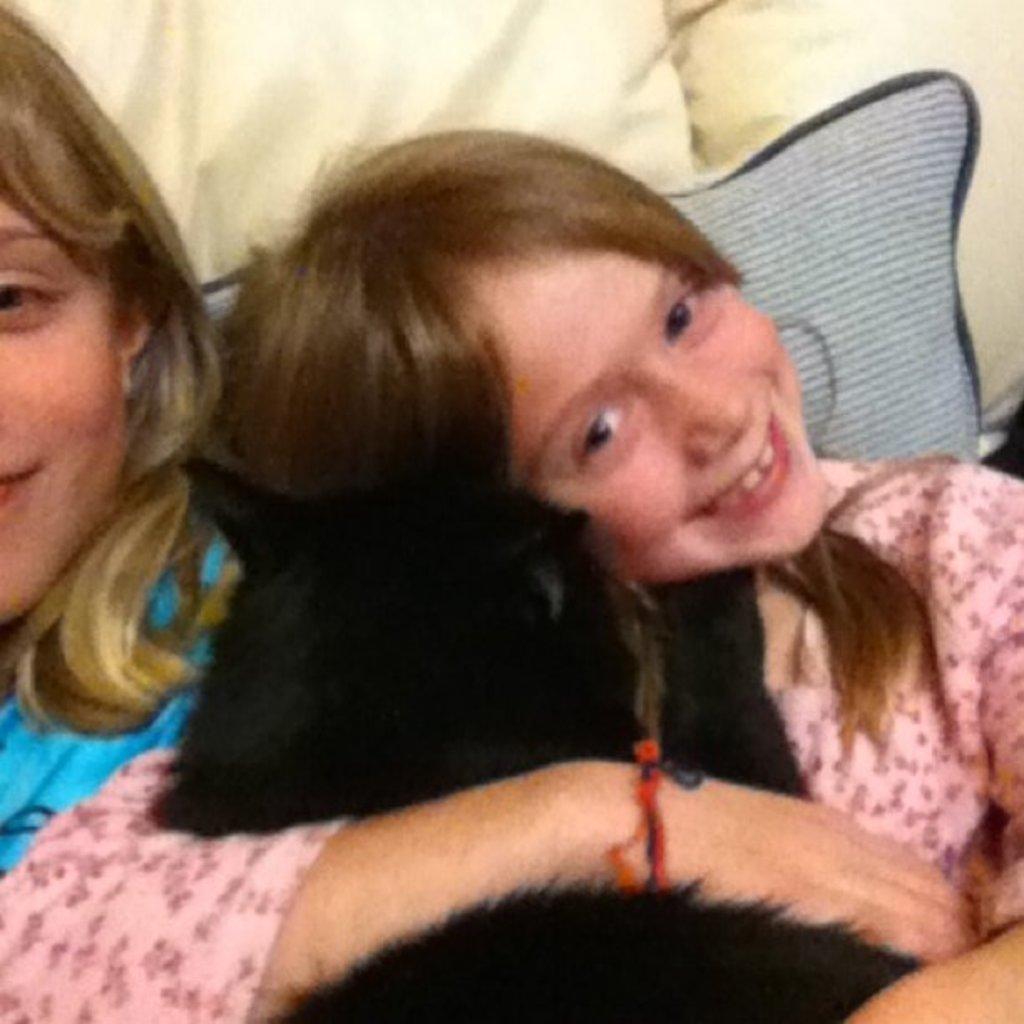In one or two sentences, can you explain what this image depicts? In the image we can see there are two girls, wearing clothes and they are smiling. These are the pillows. 